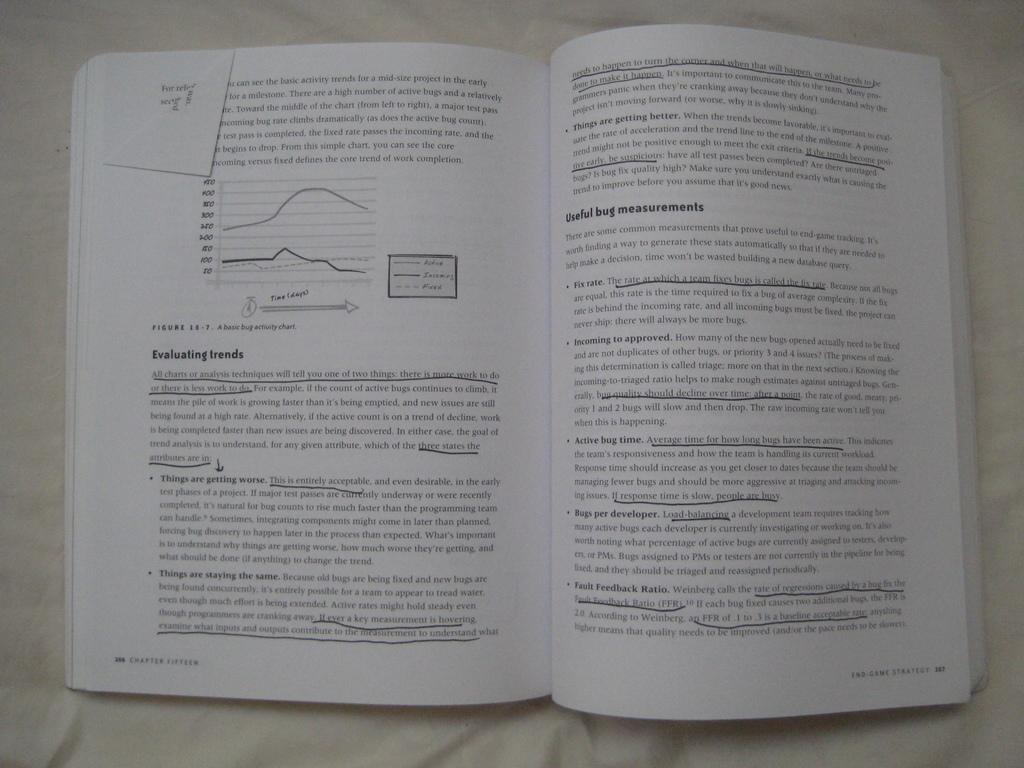<image>
Relay a brief, clear account of the picture shown. An open book with a paragraph opening with a title called evaluating trends on page 306 